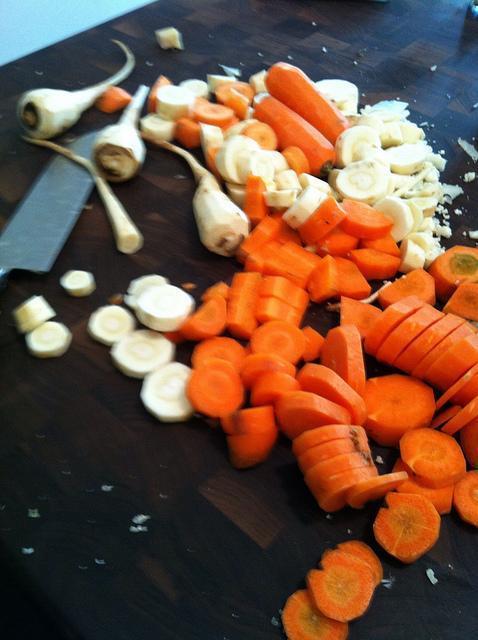How many carrots are visible?
Give a very brief answer. 11. How many red umbrellas are there?
Give a very brief answer. 0. 